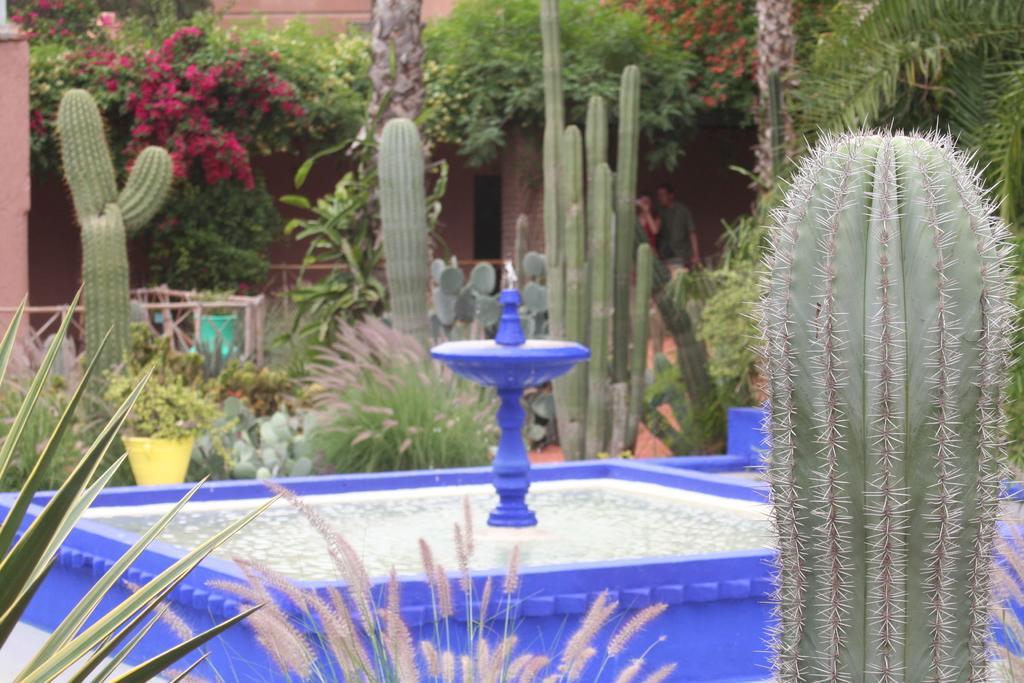Please provide a concise description of this image. In this image, we can see a water fountain, there are some cactus plants, there are some green color plants and we can see some flowers. 